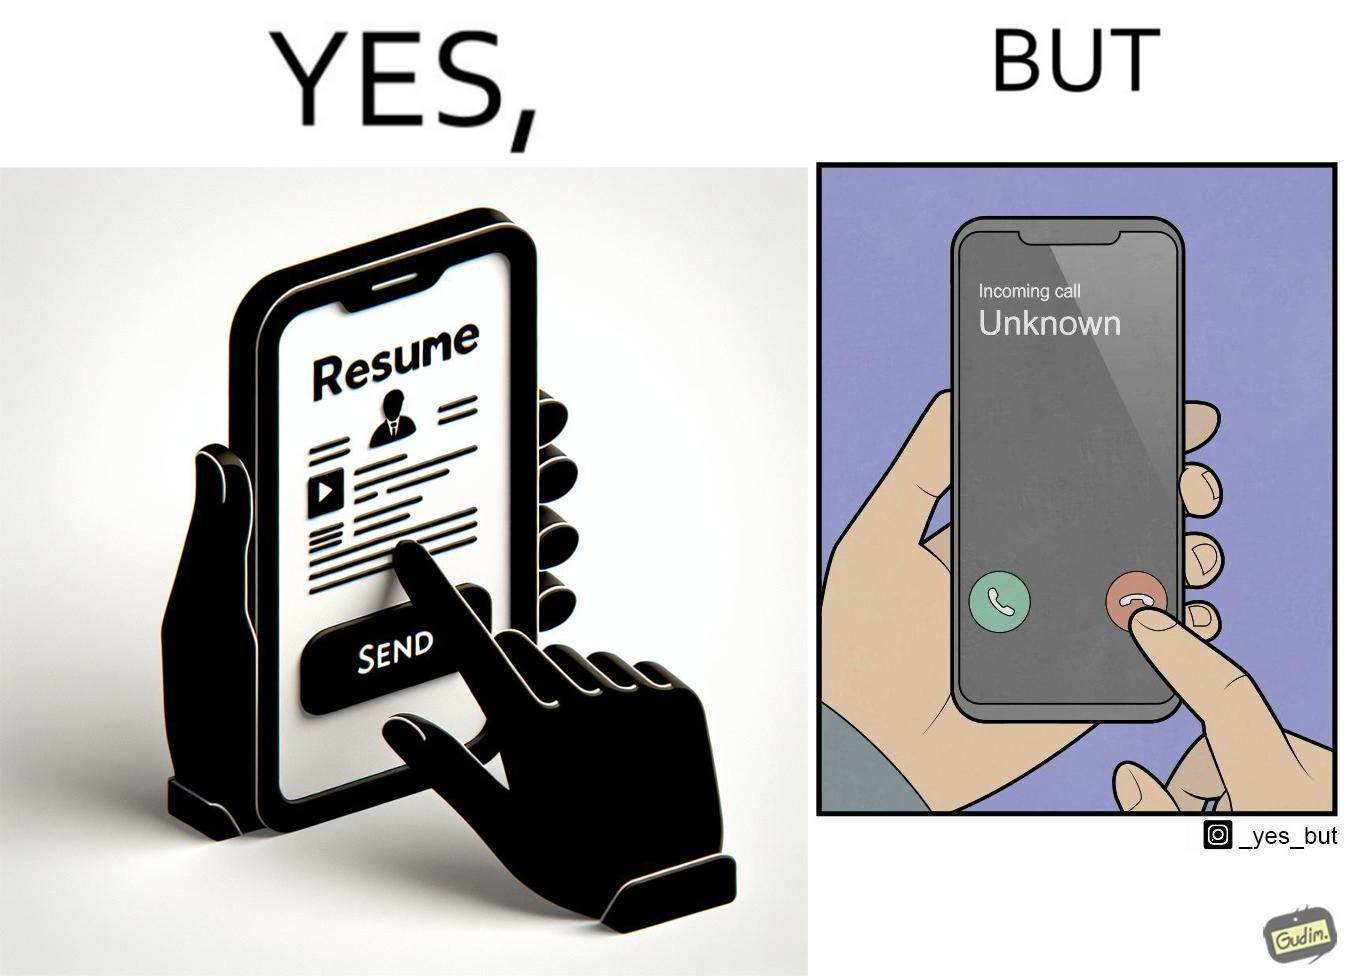Explain why this image is satirical. The image is ironic, because on the left image the person is sending their resume to someone and on the right they are rejecting the unknown calls which might be some offer calls  or the person who sent the resume maybe tired of the spam calls after sending the resume which he sent seeking some new oppurtunities 